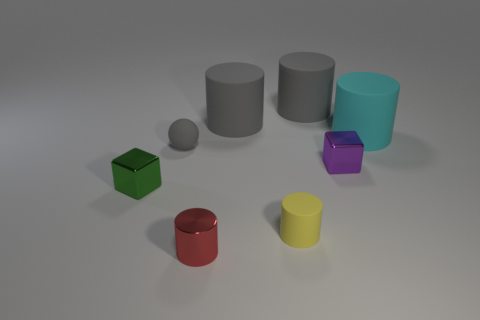Subtract all tiny metal cylinders. How many cylinders are left? 4 Subtract 2 cylinders. How many cylinders are left? 3 Subtract all yellow cylinders. How many cylinders are left? 4 Subtract all brown cylinders. Subtract all gray spheres. How many cylinders are left? 5 Add 1 metal cubes. How many objects exist? 9 Subtract all cylinders. How many objects are left? 3 Add 8 tiny shiny cylinders. How many tiny shiny cylinders are left? 9 Add 2 yellow rubber blocks. How many yellow rubber blocks exist? 2 Subtract 0 red blocks. How many objects are left? 8 Subtract all small cyan metal cubes. Subtract all red metal things. How many objects are left? 7 